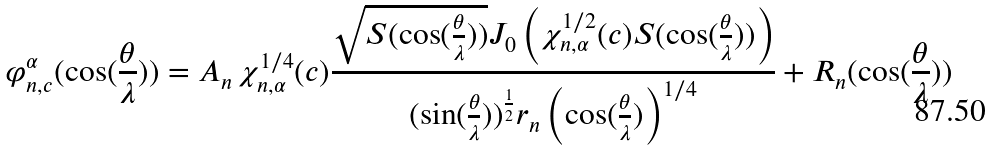<formula> <loc_0><loc_0><loc_500><loc_500>\varphi _ { n , c } ^ { \alpha } ( \cos ( \frac { \theta } { \lambda } ) ) = A _ { n } \, \chi ^ { 1 / 4 } _ { n , \alpha } ( c ) \frac { \sqrt { S ( \cos ( \frac { \theta } { \lambda } ) ) } J _ { 0 } \left ( \chi ^ { 1 / 2 } _ { n , \alpha } ( c ) S ( \cos ( \frac { \theta } { \lambda } ) ) \right ) } { ( \sin ( \frac { \theta } { \lambda } ) ) ^ { \frac { 1 } { 2 } } r _ { n } \left ( \cos ( \frac { \theta } { \lambda } ) \right ) ^ { 1 / 4 } } + R _ { n } ( \cos ( \frac { \theta } { \lambda } ) )</formula> 